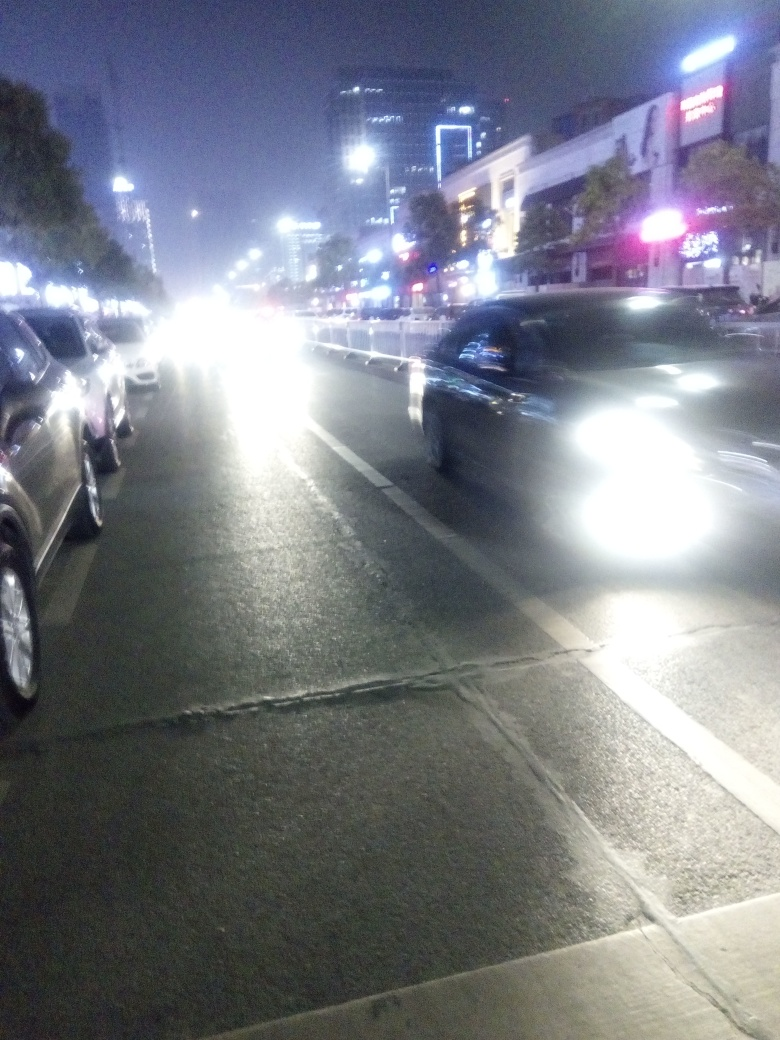Are the details and texture of the vehicles well presented? Due to the overexposure and motion blur in the image, the details and textures of the vehicles are not well presented. The bright headlights and taillights create a glare that obscures finer details, and the low light conditions contribute to a lack of sharpness in the image. 